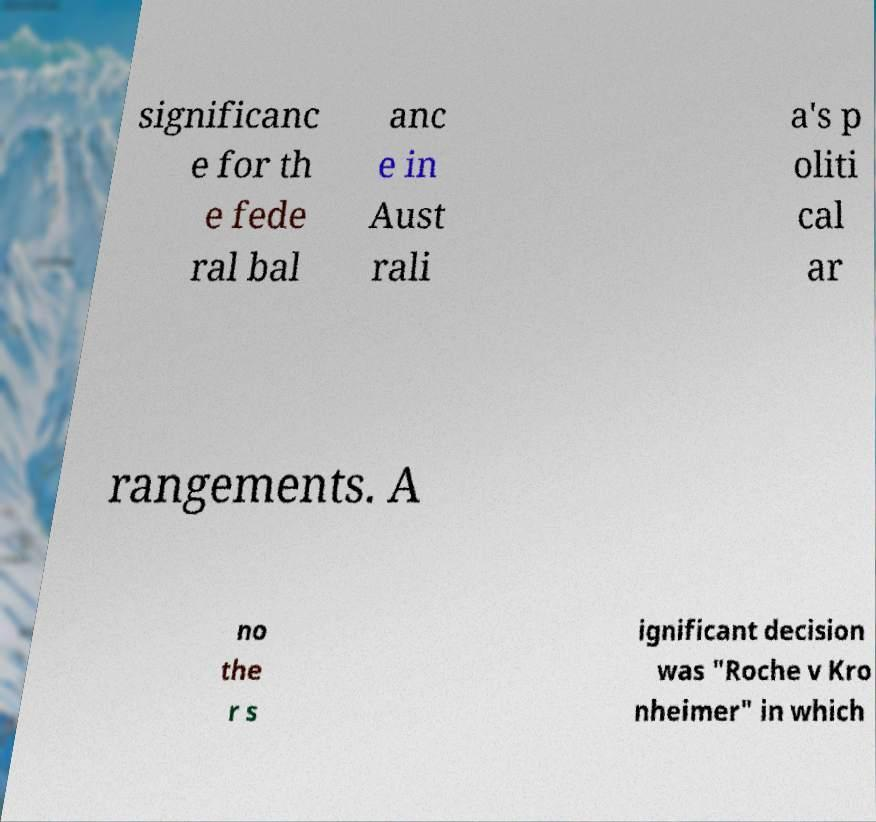What messages or text are displayed in this image? I need them in a readable, typed format. significanc e for th e fede ral bal anc e in Aust rali a's p oliti cal ar rangements. A no the r s ignificant decision was "Roche v Kro nheimer" in which 